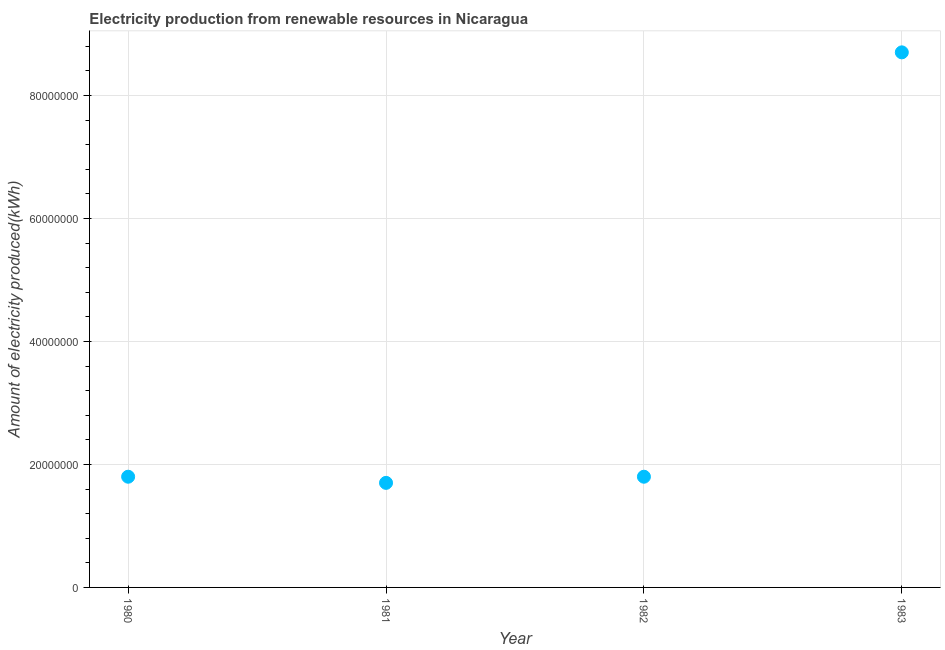What is the amount of electricity produced in 1981?
Offer a very short reply. 1.70e+07. Across all years, what is the maximum amount of electricity produced?
Ensure brevity in your answer.  8.70e+07. Across all years, what is the minimum amount of electricity produced?
Provide a short and direct response. 1.70e+07. In which year was the amount of electricity produced maximum?
Your answer should be compact. 1983. In which year was the amount of electricity produced minimum?
Offer a very short reply. 1981. What is the sum of the amount of electricity produced?
Your answer should be compact. 1.40e+08. What is the average amount of electricity produced per year?
Your response must be concise. 3.50e+07. What is the median amount of electricity produced?
Give a very brief answer. 1.80e+07. In how many years, is the amount of electricity produced greater than 56000000 kWh?
Offer a terse response. 1. What is the ratio of the amount of electricity produced in 1980 to that in 1981?
Provide a succinct answer. 1.06. Is the amount of electricity produced in 1980 less than that in 1983?
Your answer should be very brief. Yes. What is the difference between the highest and the second highest amount of electricity produced?
Offer a very short reply. 6.90e+07. What is the difference between the highest and the lowest amount of electricity produced?
Your response must be concise. 7.00e+07. In how many years, is the amount of electricity produced greater than the average amount of electricity produced taken over all years?
Your answer should be very brief. 1. How many years are there in the graph?
Your response must be concise. 4. What is the difference between two consecutive major ticks on the Y-axis?
Keep it short and to the point. 2.00e+07. What is the title of the graph?
Your response must be concise. Electricity production from renewable resources in Nicaragua. What is the label or title of the Y-axis?
Keep it short and to the point. Amount of electricity produced(kWh). What is the Amount of electricity produced(kWh) in 1980?
Make the answer very short. 1.80e+07. What is the Amount of electricity produced(kWh) in 1981?
Provide a succinct answer. 1.70e+07. What is the Amount of electricity produced(kWh) in 1982?
Your answer should be very brief. 1.80e+07. What is the Amount of electricity produced(kWh) in 1983?
Make the answer very short. 8.70e+07. What is the difference between the Amount of electricity produced(kWh) in 1980 and 1983?
Keep it short and to the point. -6.90e+07. What is the difference between the Amount of electricity produced(kWh) in 1981 and 1982?
Provide a short and direct response. -1.00e+06. What is the difference between the Amount of electricity produced(kWh) in 1981 and 1983?
Keep it short and to the point. -7.00e+07. What is the difference between the Amount of electricity produced(kWh) in 1982 and 1983?
Provide a short and direct response. -6.90e+07. What is the ratio of the Amount of electricity produced(kWh) in 1980 to that in 1981?
Offer a terse response. 1.06. What is the ratio of the Amount of electricity produced(kWh) in 1980 to that in 1983?
Offer a very short reply. 0.21. What is the ratio of the Amount of electricity produced(kWh) in 1981 to that in 1982?
Your answer should be very brief. 0.94. What is the ratio of the Amount of electricity produced(kWh) in 1981 to that in 1983?
Your answer should be compact. 0.2. What is the ratio of the Amount of electricity produced(kWh) in 1982 to that in 1983?
Provide a short and direct response. 0.21. 